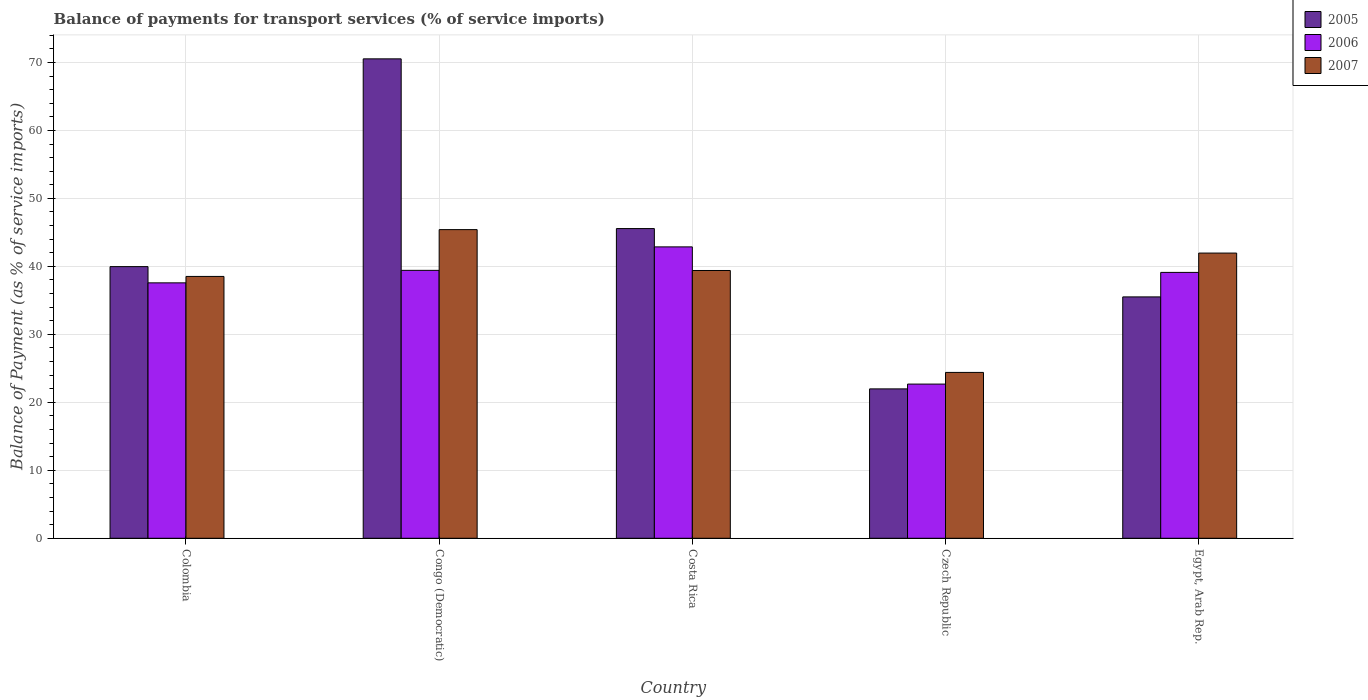Are the number of bars per tick equal to the number of legend labels?
Offer a very short reply. Yes. Are the number of bars on each tick of the X-axis equal?
Provide a succinct answer. Yes. How many bars are there on the 4th tick from the right?
Provide a short and direct response. 3. What is the label of the 5th group of bars from the left?
Keep it short and to the point. Egypt, Arab Rep. What is the balance of payments for transport services in 2007 in Czech Republic?
Make the answer very short. 24.4. Across all countries, what is the maximum balance of payments for transport services in 2006?
Your answer should be compact. 42.87. Across all countries, what is the minimum balance of payments for transport services in 2005?
Your answer should be compact. 21.98. In which country was the balance of payments for transport services in 2005 maximum?
Give a very brief answer. Congo (Democratic). In which country was the balance of payments for transport services in 2007 minimum?
Make the answer very short. Czech Republic. What is the total balance of payments for transport services in 2007 in the graph?
Your answer should be compact. 189.67. What is the difference between the balance of payments for transport services in 2005 in Colombia and that in Czech Republic?
Give a very brief answer. 17.99. What is the difference between the balance of payments for transport services in 2007 in Colombia and the balance of payments for transport services in 2005 in Czech Republic?
Keep it short and to the point. 16.54. What is the average balance of payments for transport services in 2005 per country?
Give a very brief answer. 42.71. What is the difference between the balance of payments for transport services of/in 2005 and balance of payments for transport services of/in 2006 in Colombia?
Your response must be concise. 2.39. In how many countries, is the balance of payments for transport services in 2005 greater than 14 %?
Provide a short and direct response. 5. What is the ratio of the balance of payments for transport services in 2005 in Colombia to that in Congo (Democratic)?
Offer a very short reply. 0.57. What is the difference between the highest and the second highest balance of payments for transport services in 2005?
Provide a short and direct response. -24.97. What is the difference between the highest and the lowest balance of payments for transport services in 2007?
Ensure brevity in your answer.  21.01. What does the 1st bar from the left in Colombia represents?
Give a very brief answer. 2005. What does the 1st bar from the right in Colombia represents?
Offer a terse response. 2007. Is it the case that in every country, the sum of the balance of payments for transport services in 2007 and balance of payments for transport services in 2005 is greater than the balance of payments for transport services in 2006?
Keep it short and to the point. Yes. Are the values on the major ticks of Y-axis written in scientific E-notation?
Your answer should be compact. No. Does the graph contain any zero values?
Make the answer very short. No. How many legend labels are there?
Ensure brevity in your answer.  3. What is the title of the graph?
Your answer should be compact. Balance of payments for transport services (% of service imports). Does "2015" appear as one of the legend labels in the graph?
Offer a terse response. No. What is the label or title of the Y-axis?
Your answer should be compact. Balance of Payment (as % of service imports). What is the Balance of Payment (as % of service imports) in 2005 in Colombia?
Keep it short and to the point. 39.96. What is the Balance of Payment (as % of service imports) in 2006 in Colombia?
Provide a succinct answer. 37.57. What is the Balance of Payment (as % of service imports) of 2007 in Colombia?
Provide a short and direct response. 38.52. What is the Balance of Payment (as % of service imports) in 2005 in Congo (Democratic)?
Offer a very short reply. 70.53. What is the Balance of Payment (as % of service imports) of 2006 in Congo (Democratic)?
Make the answer very short. 39.41. What is the Balance of Payment (as % of service imports) of 2007 in Congo (Democratic)?
Your response must be concise. 45.41. What is the Balance of Payment (as % of service imports) of 2005 in Costa Rica?
Ensure brevity in your answer.  45.56. What is the Balance of Payment (as % of service imports) of 2006 in Costa Rica?
Make the answer very short. 42.87. What is the Balance of Payment (as % of service imports) in 2007 in Costa Rica?
Keep it short and to the point. 39.39. What is the Balance of Payment (as % of service imports) of 2005 in Czech Republic?
Provide a short and direct response. 21.98. What is the Balance of Payment (as % of service imports) in 2006 in Czech Republic?
Your response must be concise. 22.68. What is the Balance of Payment (as % of service imports) in 2007 in Czech Republic?
Your response must be concise. 24.4. What is the Balance of Payment (as % of service imports) of 2005 in Egypt, Arab Rep.?
Provide a short and direct response. 35.51. What is the Balance of Payment (as % of service imports) of 2006 in Egypt, Arab Rep.?
Ensure brevity in your answer.  39.11. What is the Balance of Payment (as % of service imports) of 2007 in Egypt, Arab Rep.?
Provide a succinct answer. 41.96. Across all countries, what is the maximum Balance of Payment (as % of service imports) in 2005?
Your answer should be compact. 70.53. Across all countries, what is the maximum Balance of Payment (as % of service imports) in 2006?
Offer a very short reply. 42.87. Across all countries, what is the maximum Balance of Payment (as % of service imports) of 2007?
Your response must be concise. 45.41. Across all countries, what is the minimum Balance of Payment (as % of service imports) in 2005?
Ensure brevity in your answer.  21.98. Across all countries, what is the minimum Balance of Payment (as % of service imports) in 2006?
Keep it short and to the point. 22.68. Across all countries, what is the minimum Balance of Payment (as % of service imports) in 2007?
Provide a short and direct response. 24.4. What is the total Balance of Payment (as % of service imports) of 2005 in the graph?
Your answer should be compact. 213.54. What is the total Balance of Payment (as % of service imports) of 2006 in the graph?
Your answer should be very brief. 181.65. What is the total Balance of Payment (as % of service imports) of 2007 in the graph?
Your answer should be compact. 189.67. What is the difference between the Balance of Payment (as % of service imports) of 2005 in Colombia and that in Congo (Democratic)?
Keep it short and to the point. -30.56. What is the difference between the Balance of Payment (as % of service imports) of 2006 in Colombia and that in Congo (Democratic)?
Offer a very short reply. -1.84. What is the difference between the Balance of Payment (as % of service imports) in 2007 in Colombia and that in Congo (Democratic)?
Keep it short and to the point. -6.89. What is the difference between the Balance of Payment (as % of service imports) in 2005 in Colombia and that in Costa Rica?
Ensure brevity in your answer.  -5.6. What is the difference between the Balance of Payment (as % of service imports) in 2006 in Colombia and that in Costa Rica?
Give a very brief answer. -5.29. What is the difference between the Balance of Payment (as % of service imports) in 2007 in Colombia and that in Costa Rica?
Make the answer very short. -0.87. What is the difference between the Balance of Payment (as % of service imports) of 2005 in Colombia and that in Czech Republic?
Offer a terse response. 17.99. What is the difference between the Balance of Payment (as % of service imports) of 2006 in Colombia and that in Czech Republic?
Provide a succinct answer. 14.89. What is the difference between the Balance of Payment (as % of service imports) in 2007 in Colombia and that in Czech Republic?
Offer a terse response. 14.12. What is the difference between the Balance of Payment (as % of service imports) in 2005 in Colombia and that in Egypt, Arab Rep.?
Offer a terse response. 4.45. What is the difference between the Balance of Payment (as % of service imports) of 2006 in Colombia and that in Egypt, Arab Rep.?
Make the answer very short. -1.54. What is the difference between the Balance of Payment (as % of service imports) of 2007 in Colombia and that in Egypt, Arab Rep.?
Make the answer very short. -3.44. What is the difference between the Balance of Payment (as % of service imports) in 2005 in Congo (Democratic) and that in Costa Rica?
Keep it short and to the point. 24.97. What is the difference between the Balance of Payment (as % of service imports) of 2006 in Congo (Democratic) and that in Costa Rica?
Ensure brevity in your answer.  -3.45. What is the difference between the Balance of Payment (as % of service imports) in 2007 in Congo (Democratic) and that in Costa Rica?
Provide a short and direct response. 6.01. What is the difference between the Balance of Payment (as % of service imports) of 2005 in Congo (Democratic) and that in Czech Republic?
Your answer should be compact. 48.55. What is the difference between the Balance of Payment (as % of service imports) of 2006 in Congo (Democratic) and that in Czech Republic?
Your answer should be very brief. 16.73. What is the difference between the Balance of Payment (as % of service imports) in 2007 in Congo (Democratic) and that in Czech Republic?
Your answer should be very brief. 21.01. What is the difference between the Balance of Payment (as % of service imports) of 2005 in Congo (Democratic) and that in Egypt, Arab Rep.?
Your response must be concise. 35.02. What is the difference between the Balance of Payment (as % of service imports) of 2006 in Congo (Democratic) and that in Egypt, Arab Rep.?
Offer a very short reply. 0.3. What is the difference between the Balance of Payment (as % of service imports) of 2007 in Congo (Democratic) and that in Egypt, Arab Rep.?
Give a very brief answer. 3.45. What is the difference between the Balance of Payment (as % of service imports) in 2005 in Costa Rica and that in Czech Republic?
Keep it short and to the point. 23.58. What is the difference between the Balance of Payment (as % of service imports) in 2006 in Costa Rica and that in Czech Republic?
Offer a very short reply. 20.18. What is the difference between the Balance of Payment (as % of service imports) in 2007 in Costa Rica and that in Czech Republic?
Ensure brevity in your answer.  14.99. What is the difference between the Balance of Payment (as % of service imports) in 2005 in Costa Rica and that in Egypt, Arab Rep.?
Ensure brevity in your answer.  10.05. What is the difference between the Balance of Payment (as % of service imports) of 2006 in Costa Rica and that in Egypt, Arab Rep.?
Your response must be concise. 3.75. What is the difference between the Balance of Payment (as % of service imports) in 2007 in Costa Rica and that in Egypt, Arab Rep.?
Your response must be concise. -2.56. What is the difference between the Balance of Payment (as % of service imports) in 2005 in Czech Republic and that in Egypt, Arab Rep.?
Give a very brief answer. -13.53. What is the difference between the Balance of Payment (as % of service imports) of 2006 in Czech Republic and that in Egypt, Arab Rep.?
Your answer should be very brief. -16.43. What is the difference between the Balance of Payment (as % of service imports) in 2007 in Czech Republic and that in Egypt, Arab Rep.?
Offer a terse response. -17.56. What is the difference between the Balance of Payment (as % of service imports) in 2005 in Colombia and the Balance of Payment (as % of service imports) in 2006 in Congo (Democratic)?
Offer a very short reply. 0.55. What is the difference between the Balance of Payment (as % of service imports) in 2005 in Colombia and the Balance of Payment (as % of service imports) in 2007 in Congo (Democratic)?
Keep it short and to the point. -5.44. What is the difference between the Balance of Payment (as % of service imports) of 2006 in Colombia and the Balance of Payment (as % of service imports) of 2007 in Congo (Democratic)?
Your response must be concise. -7.83. What is the difference between the Balance of Payment (as % of service imports) of 2005 in Colombia and the Balance of Payment (as % of service imports) of 2006 in Costa Rica?
Your answer should be compact. -2.9. What is the difference between the Balance of Payment (as % of service imports) in 2005 in Colombia and the Balance of Payment (as % of service imports) in 2007 in Costa Rica?
Provide a short and direct response. 0.57. What is the difference between the Balance of Payment (as % of service imports) in 2006 in Colombia and the Balance of Payment (as % of service imports) in 2007 in Costa Rica?
Ensure brevity in your answer.  -1.82. What is the difference between the Balance of Payment (as % of service imports) in 2005 in Colombia and the Balance of Payment (as % of service imports) in 2006 in Czech Republic?
Your response must be concise. 17.28. What is the difference between the Balance of Payment (as % of service imports) of 2005 in Colombia and the Balance of Payment (as % of service imports) of 2007 in Czech Republic?
Offer a very short reply. 15.56. What is the difference between the Balance of Payment (as % of service imports) of 2006 in Colombia and the Balance of Payment (as % of service imports) of 2007 in Czech Republic?
Keep it short and to the point. 13.18. What is the difference between the Balance of Payment (as % of service imports) in 2005 in Colombia and the Balance of Payment (as % of service imports) in 2006 in Egypt, Arab Rep.?
Make the answer very short. 0.85. What is the difference between the Balance of Payment (as % of service imports) of 2005 in Colombia and the Balance of Payment (as % of service imports) of 2007 in Egypt, Arab Rep.?
Make the answer very short. -1.99. What is the difference between the Balance of Payment (as % of service imports) of 2006 in Colombia and the Balance of Payment (as % of service imports) of 2007 in Egypt, Arab Rep.?
Your answer should be very brief. -4.38. What is the difference between the Balance of Payment (as % of service imports) of 2005 in Congo (Democratic) and the Balance of Payment (as % of service imports) of 2006 in Costa Rica?
Ensure brevity in your answer.  27.66. What is the difference between the Balance of Payment (as % of service imports) in 2005 in Congo (Democratic) and the Balance of Payment (as % of service imports) in 2007 in Costa Rica?
Your answer should be very brief. 31.13. What is the difference between the Balance of Payment (as % of service imports) in 2006 in Congo (Democratic) and the Balance of Payment (as % of service imports) in 2007 in Costa Rica?
Provide a short and direct response. 0.02. What is the difference between the Balance of Payment (as % of service imports) in 2005 in Congo (Democratic) and the Balance of Payment (as % of service imports) in 2006 in Czech Republic?
Give a very brief answer. 47.84. What is the difference between the Balance of Payment (as % of service imports) in 2005 in Congo (Democratic) and the Balance of Payment (as % of service imports) in 2007 in Czech Republic?
Your response must be concise. 46.13. What is the difference between the Balance of Payment (as % of service imports) in 2006 in Congo (Democratic) and the Balance of Payment (as % of service imports) in 2007 in Czech Republic?
Ensure brevity in your answer.  15.01. What is the difference between the Balance of Payment (as % of service imports) of 2005 in Congo (Democratic) and the Balance of Payment (as % of service imports) of 2006 in Egypt, Arab Rep.?
Keep it short and to the point. 31.41. What is the difference between the Balance of Payment (as % of service imports) in 2005 in Congo (Democratic) and the Balance of Payment (as % of service imports) in 2007 in Egypt, Arab Rep.?
Your response must be concise. 28.57. What is the difference between the Balance of Payment (as % of service imports) in 2006 in Congo (Democratic) and the Balance of Payment (as % of service imports) in 2007 in Egypt, Arab Rep.?
Ensure brevity in your answer.  -2.54. What is the difference between the Balance of Payment (as % of service imports) of 2005 in Costa Rica and the Balance of Payment (as % of service imports) of 2006 in Czech Republic?
Make the answer very short. 22.88. What is the difference between the Balance of Payment (as % of service imports) of 2005 in Costa Rica and the Balance of Payment (as % of service imports) of 2007 in Czech Republic?
Give a very brief answer. 21.16. What is the difference between the Balance of Payment (as % of service imports) in 2006 in Costa Rica and the Balance of Payment (as % of service imports) in 2007 in Czech Republic?
Your answer should be compact. 18.47. What is the difference between the Balance of Payment (as % of service imports) of 2005 in Costa Rica and the Balance of Payment (as % of service imports) of 2006 in Egypt, Arab Rep.?
Ensure brevity in your answer.  6.45. What is the difference between the Balance of Payment (as % of service imports) in 2005 in Costa Rica and the Balance of Payment (as % of service imports) in 2007 in Egypt, Arab Rep.?
Offer a very short reply. 3.61. What is the difference between the Balance of Payment (as % of service imports) of 2006 in Costa Rica and the Balance of Payment (as % of service imports) of 2007 in Egypt, Arab Rep.?
Ensure brevity in your answer.  0.91. What is the difference between the Balance of Payment (as % of service imports) in 2005 in Czech Republic and the Balance of Payment (as % of service imports) in 2006 in Egypt, Arab Rep.?
Provide a short and direct response. -17.14. What is the difference between the Balance of Payment (as % of service imports) of 2005 in Czech Republic and the Balance of Payment (as % of service imports) of 2007 in Egypt, Arab Rep.?
Keep it short and to the point. -19.98. What is the difference between the Balance of Payment (as % of service imports) in 2006 in Czech Republic and the Balance of Payment (as % of service imports) in 2007 in Egypt, Arab Rep.?
Give a very brief answer. -19.27. What is the average Balance of Payment (as % of service imports) of 2005 per country?
Provide a succinct answer. 42.71. What is the average Balance of Payment (as % of service imports) of 2006 per country?
Keep it short and to the point. 36.33. What is the average Balance of Payment (as % of service imports) in 2007 per country?
Your response must be concise. 37.93. What is the difference between the Balance of Payment (as % of service imports) of 2005 and Balance of Payment (as % of service imports) of 2006 in Colombia?
Provide a short and direct response. 2.39. What is the difference between the Balance of Payment (as % of service imports) in 2005 and Balance of Payment (as % of service imports) in 2007 in Colombia?
Provide a succinct answer. 1.44. What is the difference between the Balance of Payment (as % of service imports) in 2006 and Balance of Payment (as % of service imports) in 2007 in Colombia?
Your answer should be compact. -0.95. What is the difference between the Balance of Payment (as % of service imports) of 2005 and Balance of Payment (as % of service imports) of 2006 in Congo (Democratic)?
Offer a terse response. 31.11. What is the difference between the Balance of Payment (as % of service imports) in 2005 and Balance of Payment (as % of service imports) in 2007 in Congo (Democratic)?
Ensure brevity in your answer.  25.12. What is the difference between the Balance of Payment (as % of service imports) in 2006 and Balance of Payment (as % of service imports) in 2007 in Congo (Democratic)?
Give a very brief answer. -5.99. What is the difference between the Balance of Payment (as % of service imports) of 2005 and Balance of Payment (as % of service imports) of 2006 in Costa Rica?
Offer a terse response. 2.69. What is the difference between the Balance of Payment (as % of service imports) in 2005 and Balance of Payment (as % of service imports) in 2007 in Costa Rica?
Make the answer very short. 6.17. What is the difference between the Balance of Payment (as % of service imports) in 2006 and Balance of Payment (as % of service imports) in 2007 in Costa Rica?
Offer a terse response. 3.47. What is the difference between the Balance of Payment (as % of service imports) of 2005 and Balance of Payment (as % of service imports) of 2006 in Czech Republic?
Offer a very short reply. -0.71. What is the difference between the Balance of Payment (as % of service imports) of 2005 and Balance of Payment (as % of service imports) of 2007 in Czech Republic?
Ensure brevity in your answer.  -2.42. What is the difference between the Balance of Payment (as % of service imports) in 2006 and Balance of Payment (as % of service imports) in 2007 in Czech Republic?
Your response must be concise. -1.72. What is the difference between the Balance of Payment (as % of service imports) of 2005 and Balance of Payment (as % of service imports) of 2006 in Egypt, Arab Rep.?
Give a very brief answer. -3.6. What is the difference between the Balance of Payment (as % of service imports) of 2005 and Balance of Payment (as % of service imports) of 2007 in Egypt, Arab Rep.?
Your response must be concise. -6.45. What is the difference between the Balance of Payment (as % of service imports) of 2006 and Balance of Payment (as % of service imports) of 2007 in Egypt, Arab Rep.?
Your answer should be very brief. -2.84. What is the ratio of the Balance of Payment (as % of service imports) in 2005 in Colombia to that in Congo (Democratic)?
Provide a short and direct response. 0.57. What is the ratio of the Balance of Payment (as % of service imports) of 2006 in Colombia to that in Congo (Democratic)?
Provide a succinct answer. 0.95. What is the ratio of the Balance of Payment (as % of service imports) of 2007 in Colombia to that in Congo (Democratic)?
Offer a terse response. 0.85. What is the ratio of the Balance of Payment (as % of service imports) of 2005 in Colombia to that in Costa Rica?
Provide a succinct answer. 0.88. What is the ratio of the Balance of Payment (as % of service imports) of 2006 in Colombia to that in Costa Rica?
Your answer should be very brief. 0.88. What is the ratio of the Balance of Payment (as % of service imports) in 2007 in Colombia to that in Costa Rica?
Give a very brief answer. 0.98. What is the ratio of the Balance of Payment (as % of service imports) of 2005 in Colombia to that in Czech Republic?
Your answer should be compact. 1.82. What is the ratio of the Balance of Payment (as % of service imports) of 2006 in Colombia to that in Czech Republic?
Your response must be concise. 1.66. What is the ratio of the Balance of Payment (as % of service imports) of 2007 in Colombia to that in Czech Republic?
Your answer should be very brief. 1.58. What is the ratio of the Balance of Payment (as % of service imports) of 2005 in Colombia to that in Egypt, Arab Rep.?
Offer a terse response. 1.13. What is the ratio of the Balance of Payment (as % of service imports) of 2006 in Colombia to that in Egypt, Arab Rep.?
Your answer should be compact. 0.96. What is the ratio of the Balance of Payment (as % of service imports) in 2007 in Colombia to that in Egypt, Arab Rep.?
Your answer should be very brief. 0.92. What is the ratio of the Balance of Payment (as % of service imports) of 2005 in Congo (Democratic) to that in Costa Rica?
Your response must be concise. 1.55. What is the ratio of the Balance of Payment (as % of service imports) in 2006 in Congo (Democratic) to that in Costa Rica?
Make the answer very short. 0.92. What is the ratio of the Balance of Payment (as % of service imports) of 2007 in Congo (Democratic) to that in Costa Rica?
Give a very brief answer. 1.15. What is the ratio of the Balance of Payment (as % of service imports) of 2005 in Congo (Democratic) to that in Czech Republic?
Your answer should be very brief. 3.21. What is the ratio of the Balance of Payment (as % of service imports) of 2006 in Congo (Democratic) to that in Czech Republic?
Your answer should be very brief. 1.74. What is the ratio of the Balance of Payment (as % of service imports) of 2007 in Congo (Democratic) to that in Czech Republic?
Ensure brevity in your answer.  1.86. What is the ratio of the Balance of Payment (as % of service imports) of 2005 in Congo (Democratic) to that in Egypt, Arab Rep.?
Your answer should be compact. 1.99. What is the ratio of the Balance of Payment (as % of service imports) of 2006 in Congo (Democratic) to that in Egypt, Arab Rep.?
Give a very brief answer. 1.01. What is the ratio of the Balance of Payment (as % of service imports) in 2007 in Congo (Democratic) to that in Egypt, Arab Rep.?
Offer a very short reply. 1.08. What is the ratio of the Balance of Payment (as % of service imports) of 2005 in Costa Rica to that in Czech Republic?
Offer a terse response. 2.07. What is the ratio of the Balance of Payment (as % of service imports) of 2006 in Costa Rica to that in Czech Republic?
Make the answer very short. 1.89. What is the ratio of the Balance of Payment (as % of service imports) of 2007 in Costa Rica to that in Czech Republic?
Your response must be concise. 1.61. What is the ratio of the Balance of Payment (as % of service imports) in 2005 in Costa Rica to that in Egypt, Arab Rep.?
Your response must be concise. 1.28. What is the ratio of the Balance of Payment (as % of service imports) in 2006 in Costa Rica to that in Egypt, Arab Rep.?
Keep it short and to the point. 1.1. What is the ratio of the Balance of Payment (as % of service imports) in 2007 in Costa Rica to that in Egypt, Arab Rep.?
Give a very brief answer. 0.94. What is the ratio of the Balance of Payment (as % of service imports) in 2005 in Czech Republic to that in Egypt, Arab Rep.?
Offer a very short reply. 0.62. What is the ratio of the Balance of Payment (as % of service imports) in 2006 in Czech Republic to that in Egypt, Arab Rep.?
Your response must be concise. 0.58. What is the ratio of the Balance of Payment (as % of service imports) of 2007 in Czech Republic to that in Egypt, Arab Rep.?
Give a very brief answer. 0.58. What is the difference between the highest and the second highest Balance of Payment (as % of service imports) of 2005?
Your response must be concise. 24.97. What is the difference between the highest and the second highest Balance of Payment (as % of service imports) of 2006?
Give a very brief answer. 3.45. What is the difference between the highest and the second highest Balance of Payment (as % of service imports) of 2007?
Ensure brevity in your answer.  3.45. What is the difference between the highest and the lowest Balance of Payment (as % of service imports) of 2005?
Give a very brief answer. 48.55. What is the difference between the highest and the lowest Balance of Payment (as % of service imports) in 2006?
Offer a very short reply. 20.18. What is the difference between the highest and the lowest Balance of Payment (as % of service imports) of 2007?
Provide a succinct answer. 21.01. 